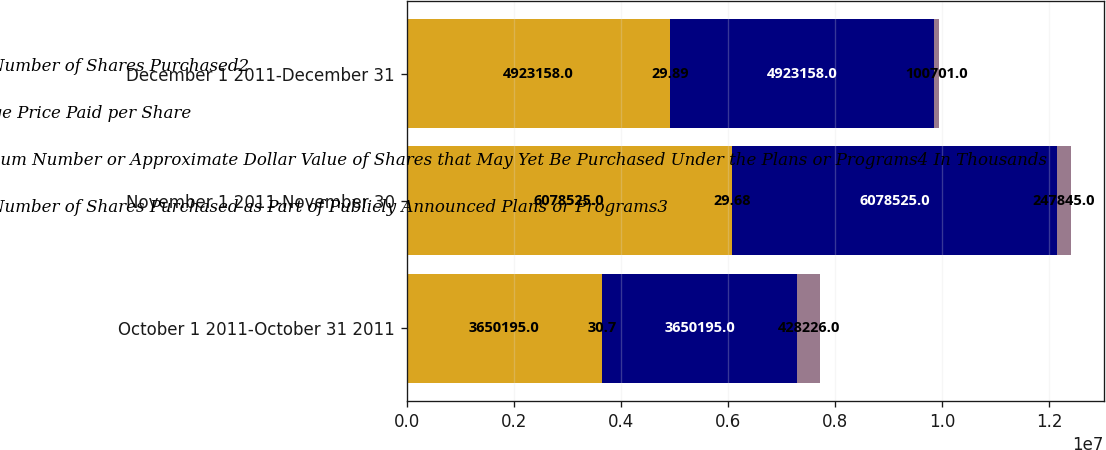Convert chart to OTSL. <chart><loc_0><loc_0><loc_500><loc_500><stacked_bar_chart><ecel><fcel>October 1 2011-October 31 2011<fcel>November 1 2011-November 30<fcel>December 1 2011-December 31<nl><fcel>Total Number of Shares Purchased2<fcel>3.6502e+06<fcel>6.07852e+06<fcel>4.92316e+06<nl><fcel>Average Price Paid per Share<fcel>30.7<fcel>29.68<fcel>29.89<nl><fcel>Maximum Number or Approximate Dollar Value of Shares that May Yet Be Purchased Under the Plans or Programs4 In Thousands<fcel>3.6502e+06<fcel>6.07852e+06<fcel>4.92316e+06<nl><fcel>Total Number of Shares Purchased as Part of Publicly Announced Plans or Programs3<fcel>428226<fcel>247845<fcel>100701<nl></chart> 